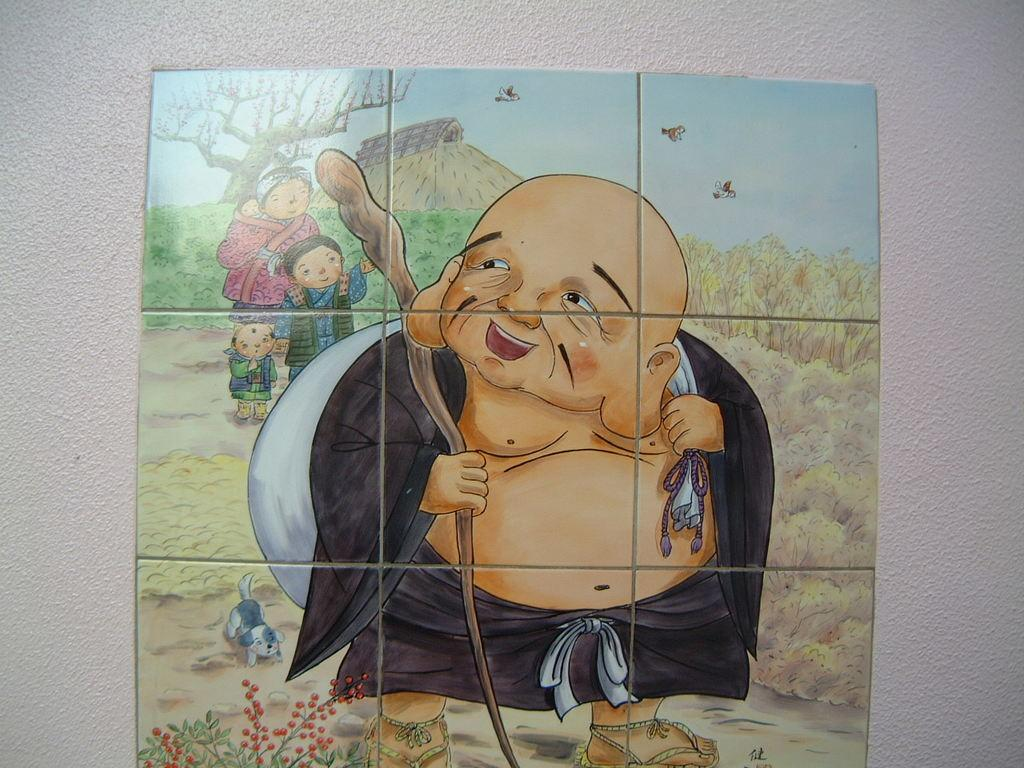What is in the center of the image? There are tiles in the center of the image. What is depicted on the tiles? There is a drawing on the tiles. What elements are included in the drawing? The drawing includes a person, mountains, trees, grass, and a dog. Are there any other elements in the drawing? Yes, there are flowers in the drawing. What can be seen in the background of the image? There is a wall in the background of the image. What type of activity is the committee conducting in the image? There is no committee or activity present in the image; it features a drawing on tiles. What is the limit of the dog's movement in the image? The image is a drawing, and the dog is not actually moving, so there is no limit to its movement. 